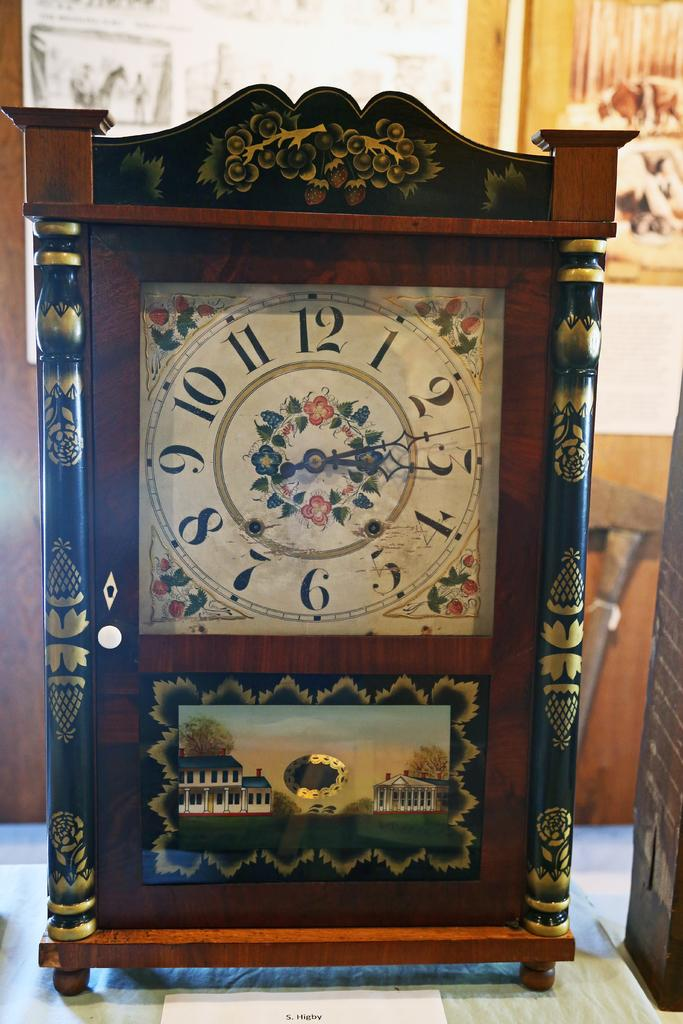<image>
Share a concise interpretation of the image provided. A table size decorative clock with the analog in script font and a small white card in front of the clock that says S Higby 